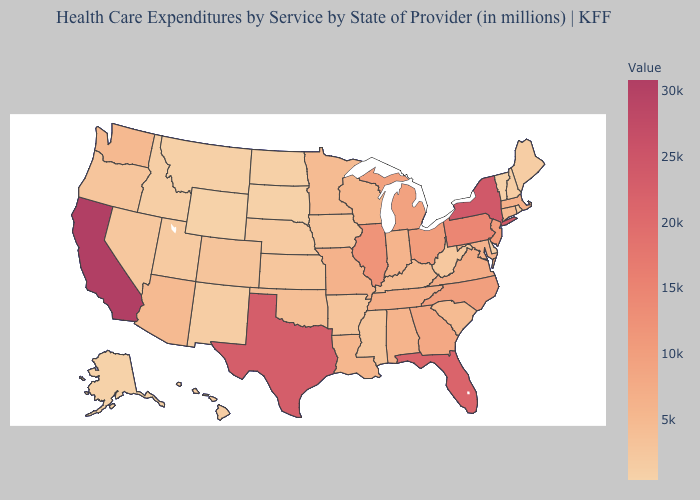Is the legend a continuous bar?
Give a very brief answer. Yes. Among the states that border Mississippi , which have the highest value?
Short answer required. Tennessee. Is the legend a continuous bar?
Give a very brief answer. Yes. Does California have the highest value in the USA?
Keep it brief. Yes. Among the states that border Alabama , does Florida have the lowest value?
Give a very brief answer. No. 